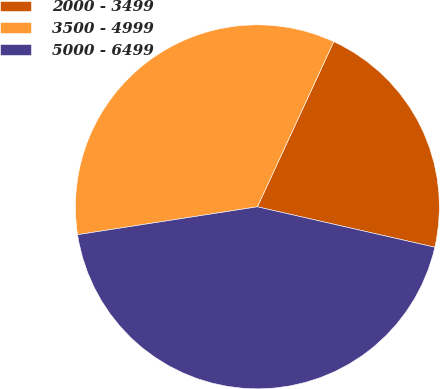Convert chart. <chart><loc_0><loc_0><loc_500><loc_500><pie_chart><fcel>2000 - 3499<fcel>3500 - 4999<fcel>5000 - 6499<nl><fcel>21.67%<fcel>34.34%<fcel>43.99%<nl></chart> 